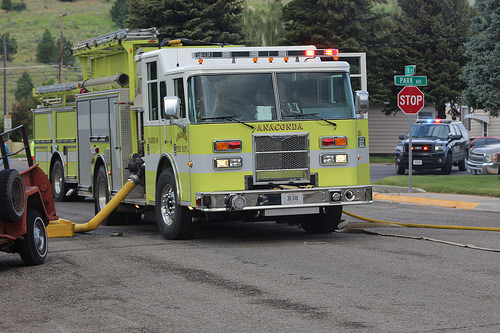<image>
Is the car next to the tire? No. The car is not positioned next to the tire. They are located in different areas of the scene. 